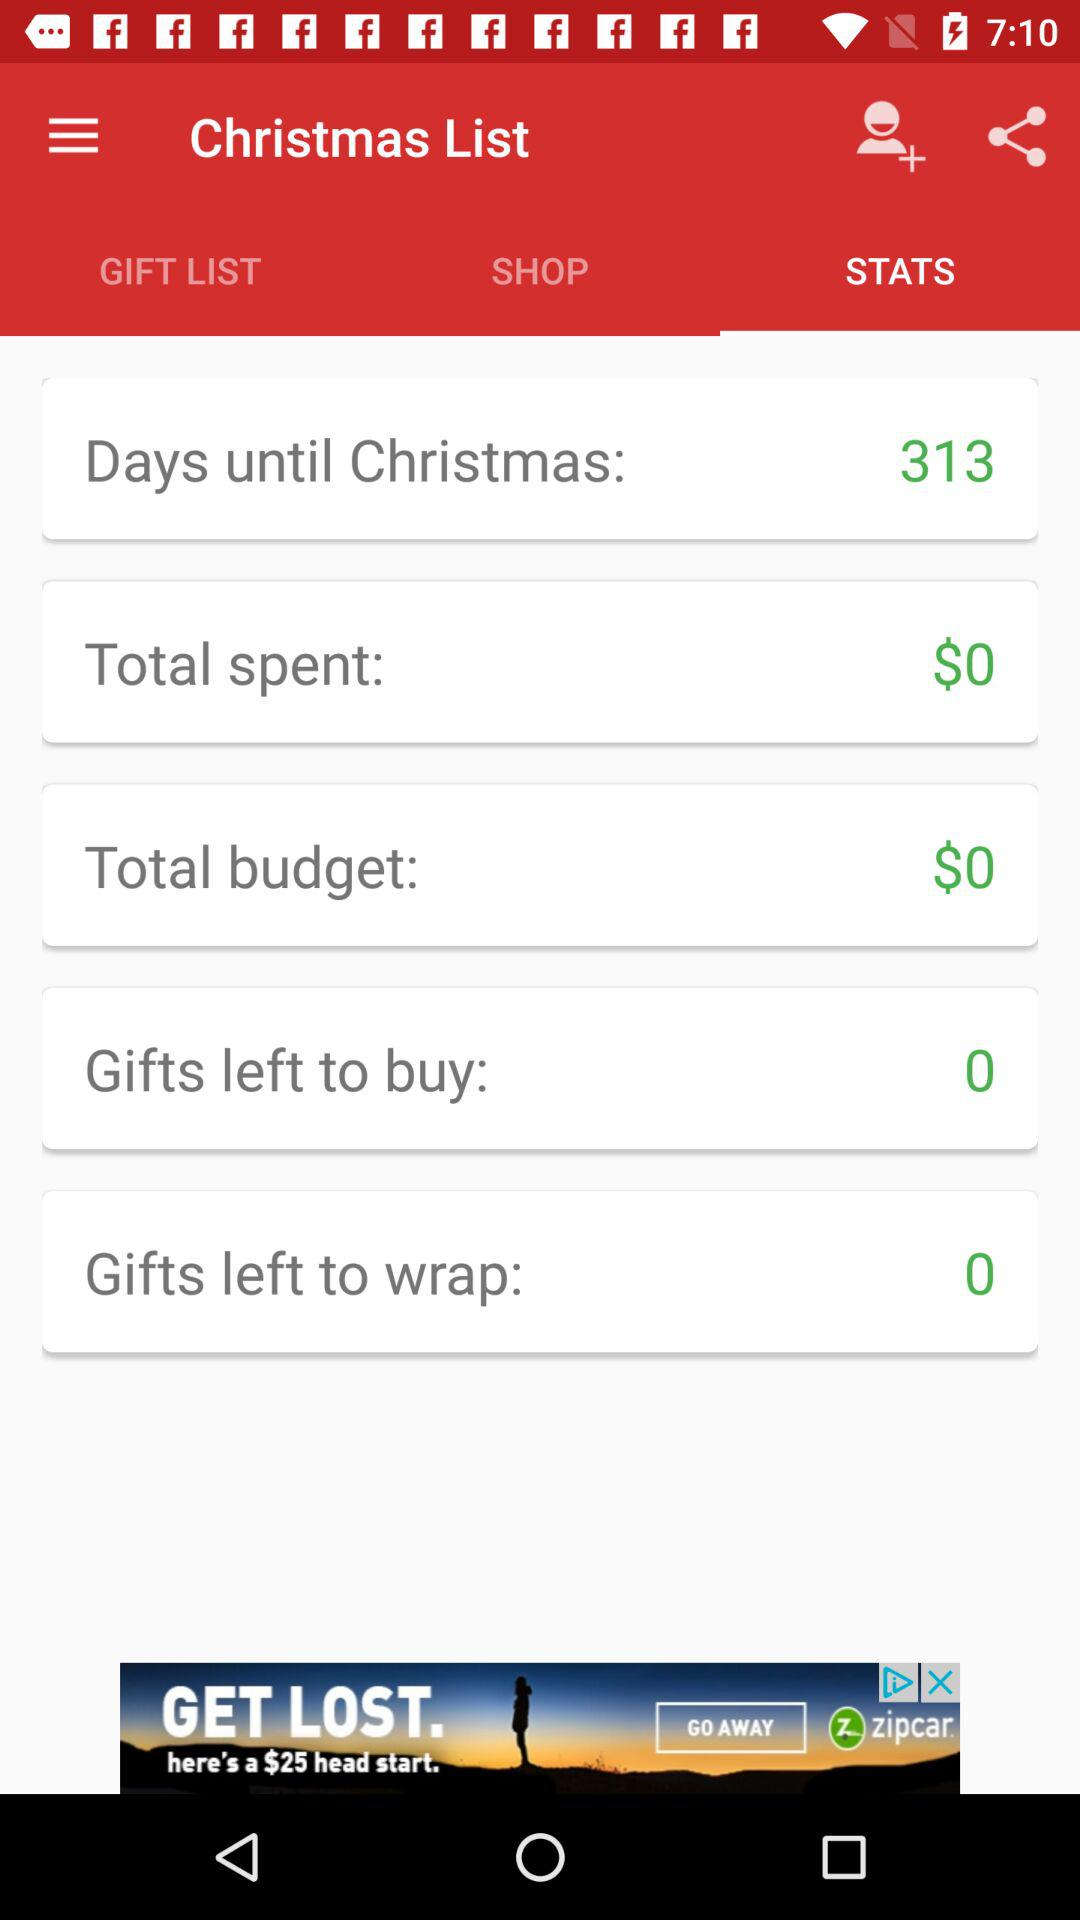How many days are left until Christmas? There are 313 days left. 